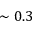<formula> <loc_0><loc_0><loc_500><loc_500>\sim 0 . 3</formula> 